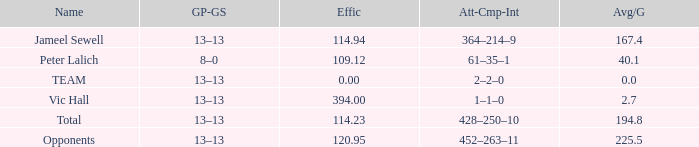Avg/g featuring a gp-gs of 13–13, and a performance below 11 1.0. 